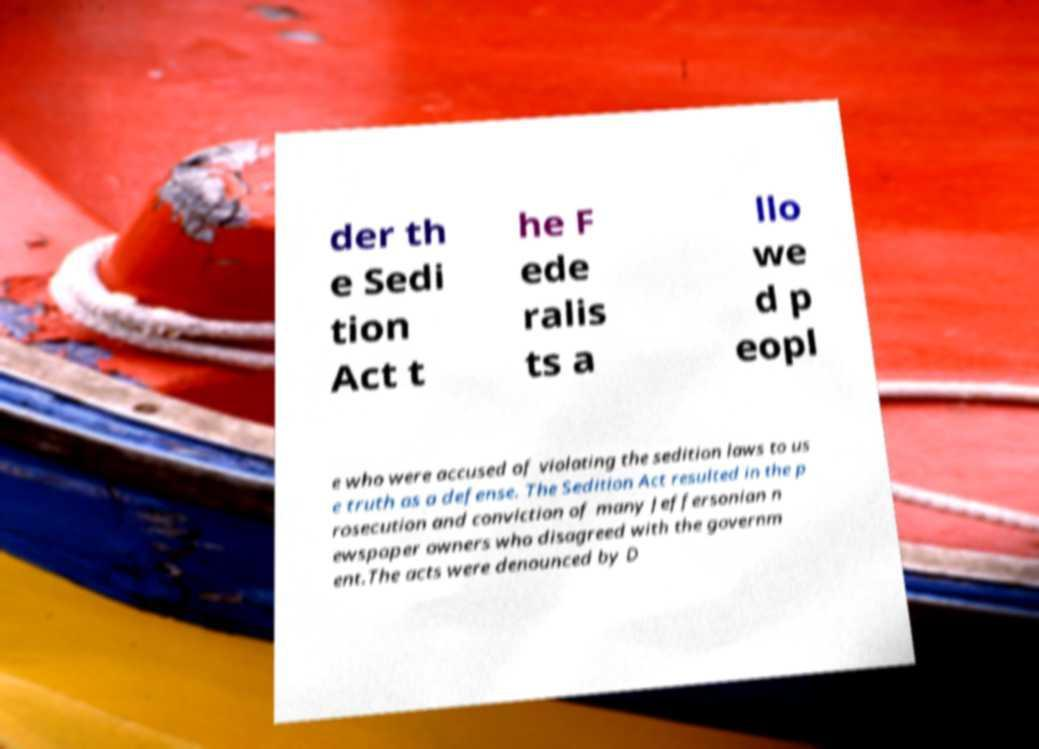There's text embedded in this image that I need extracted. Can you transcribe it verbatim? der th e Sedi tion Act t he F ede ralis ts a llo we d p eopl e who were accused of violating the sedition laws to us e truth as a defense. The Sedition Act resulted in the p rosecution and conviction of many Jeffersonian n ewspaper owners who disagreed with the governm ent.The acts were denounced by D 